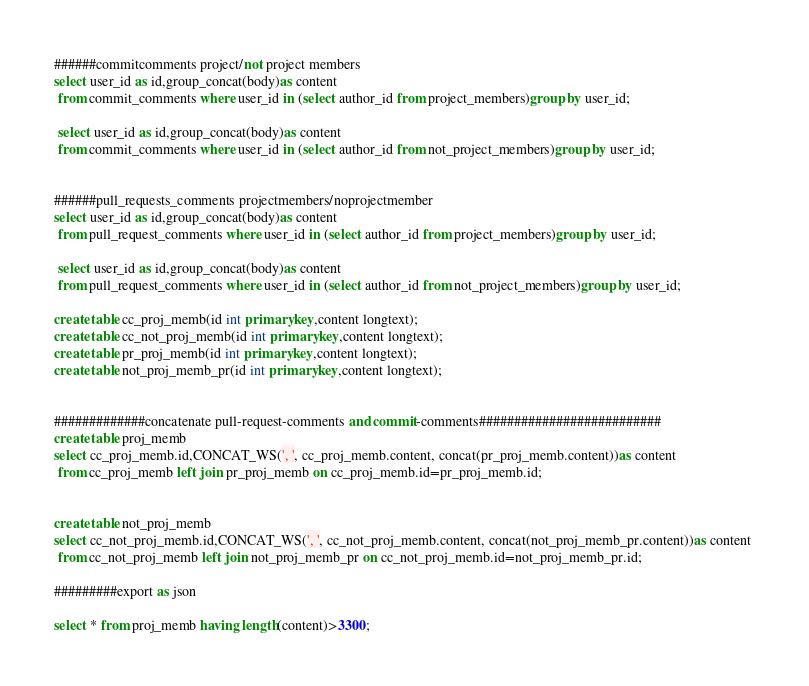<code> <loc_0><loc_0><loc_500><loc_500><_SQL_>######commitcomments project/not project members
select user_id as id,group_concat(body)as content
 from commit_comments where user_id in (select author_id from project_members)group by user_id;
 
 select user_id as id,group_concat(body)as content
 from commit_comments where user_id in (select author_id from not_project_members)group by user_id;


######pull_requests_comments projectmembers/noprojectmember
select user_id as id,group_concat(body)as content
 from pull_request_comments where user_id in (select author_id from project_members)group by user_id;
 
 select user_id as id,group_concat(body)as content
 from pull_request_comments where user_id in (select author_id from not_project_members)group by user_id;
  
create table cc_proj_memb(id int primary key,content longtext);
create table cc_not_proj_memb(id int primary key,content longtext);
create table pr_proj_memb(id int primary key,content longtext);
create table not_proj_memb_pr(id int primary key,content longtext);


#############concatenate pull-request-comments and commit-comments##########################
create table proj_memb
select cc_proj_memb.id,CONCAT_WS(', ', cc_proj_memb.content, concat(pr_proj_memb.content))as content 
 from cc_proj_memb left join pr_proj_memb on cc_proj_memb.id=pr_proj_memb.id;


create table not_proj_memb
select cc_not_proj_memb.id,CONCAT_WS(', ', cc_not_proj_memb.content, concat(not_proj_memb_pr.content))as content 
 from cc_not_proj_memb left join not_proj_memb_pr on cc_not_proj_memb.id=not_proj_memb_pr.id;
 
#########export as json

select * from proj_memb having length(content)>3300;

</code> 